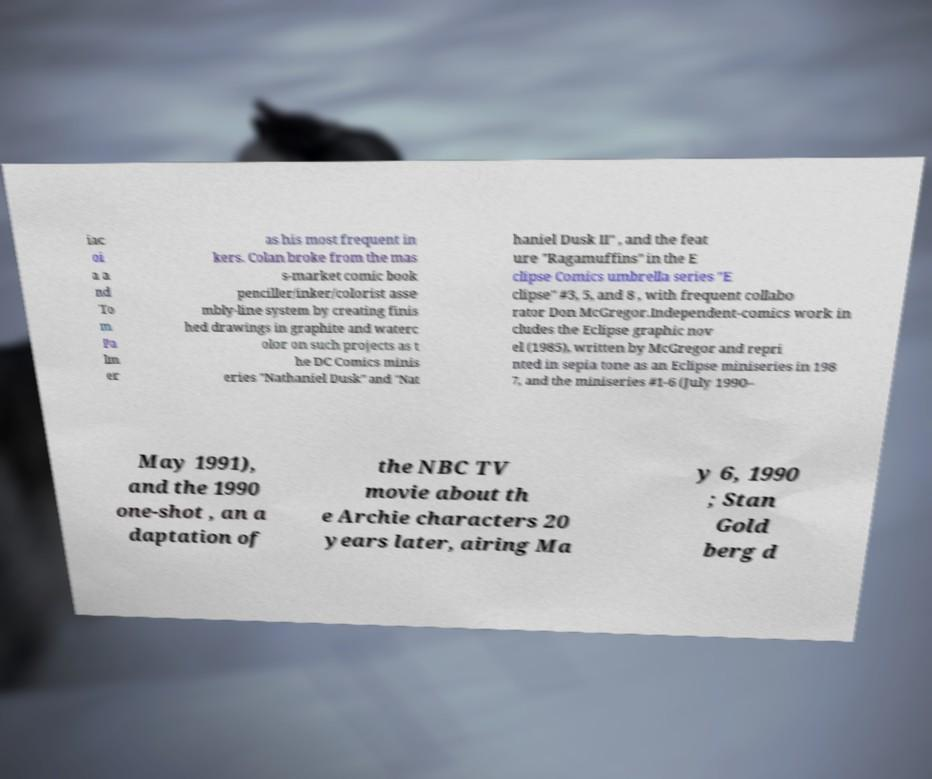For documentation purposes, I need the text within this image transcribed. Could you provide that? iac oi a a nd To m Pa lm er as his most frequent in kers. Colan broke from the mas s-market comic book penciller/inker/colorist asse mbly-line system by creating finis hed drawings in graphite and waterc olor on such projects as t he DC Comics minis eries "Nathaniel Dusk" and "Nat haniel Dusk II" , and the feat ure "Ragamuffins" in the E clipse Comics umbrella series "E clipse" #3, 5, and 8 , with frequent collabo rator Don McGregor.Independent-comics work in cludes the Eclipse graphic nov el (1985), written by McGregor and repri nted in sepia tone as an Eclipse miniseries in 198 7, and the miniseries #1-6 (July 1990– May 1991), and the 1990 one-shot , an a daptation of the NBC TV movie about th e Archie characters 20 years later, airing Ma y 6, 1990 ; Stan Gold berg d 